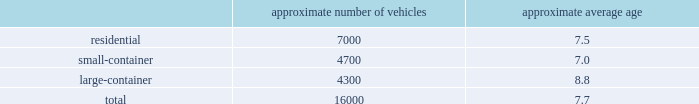Organizational structure a key enabler of the republic way operating model is our organizational structure that fosters a high performance culture by maintaining 360-degree accountability and full profit and loss responsibility with local management , supported by a functional structure to provide subject matter expertise .
This structure allows us to take advantage of our scale by coordinating functionally across all of our markets , while empowering local management to respond to unique market dynamics .
Our senior management evaluates , oversees and manages the financial performance of our operations through two field groups , referred to as group 1 and group 2 .
Group 1 primarily consists of geographic areas located in the western united states , and group 2 primarily consists of geographic areas located in the southeastern and mid-western united states , and the eastern seaboard of the united states .
Each field group is organized into several areas and each area contains multiple business units or operating locations .
Each of our field groups and all of our areas provide collection , transfer , recycling and landfill services .
See note 14 , segment reporting , to our consolidated financial statements in item 8 of this form 10-k for further discussion of our operating segments .
Through this operating model , we have rolled out several productivity and cost control initiatives designed to deliver the best service possible to our customers in an efficient and environmentally sound way .
Fleet automation approximately 75% ( 75 % ) of our residential routes have been converted to automated single-driver trucks .
By converting our residential routes to automated service , we reduce labor costs , improve driver productivity , decrease emissions and create a safer work environment for our employees .
Additionally , communities using automated vehicles have higher participation rates in recycling programs , thereby complementing our initiative to expand our recycling capabilities .
Fleet conversion to compressed natural gas ( cng ) approximately 20% ( 20 % ) of our fleet operates on natural gas .
We expect to continue our gradual fleet conversion to cng as part of our ordinary annual fleet replacement process .
We believe a gradual fleet conversion is the most prudent approach to realizing the full value of our previous fleet investments .
Approximately 13% ( 13 % ) of our replacement vehicle purchases during 2018 were cng vehicles .
We believe using cng vehicles provides us a competitive advantage in communities with strict clean emission initiatives that focus on protecting the environment .
Although upfront capital costs are higher , using cng reduces our overall fleet operating costs through lower fuel expenses .
As of december 31 , 2018 , we operated 37 cng fueling stations .
Standardized maintenance based on an industry trade publication , we operate the seventh largest vocational fleet in the united states .
As of december 31 , 2018 , our average fleet age in years , by line of business , was as follows : approximate number of vehicles approximate average age .
Onefleet , our standardized vehicle maintenance program , enables us to use best practices for fleet management , truck care and maintenance .
Through standardization of core functions , we believe we can minimize variability .
As part of the total fleet what is the approximate number of vehicles converted to cng? 
Rationale: the approximate number of vehicles the total number of vehicles multiply by vehicle coversiion percent
Computations: (16000 * 20%)
Answer: 3200.0. 